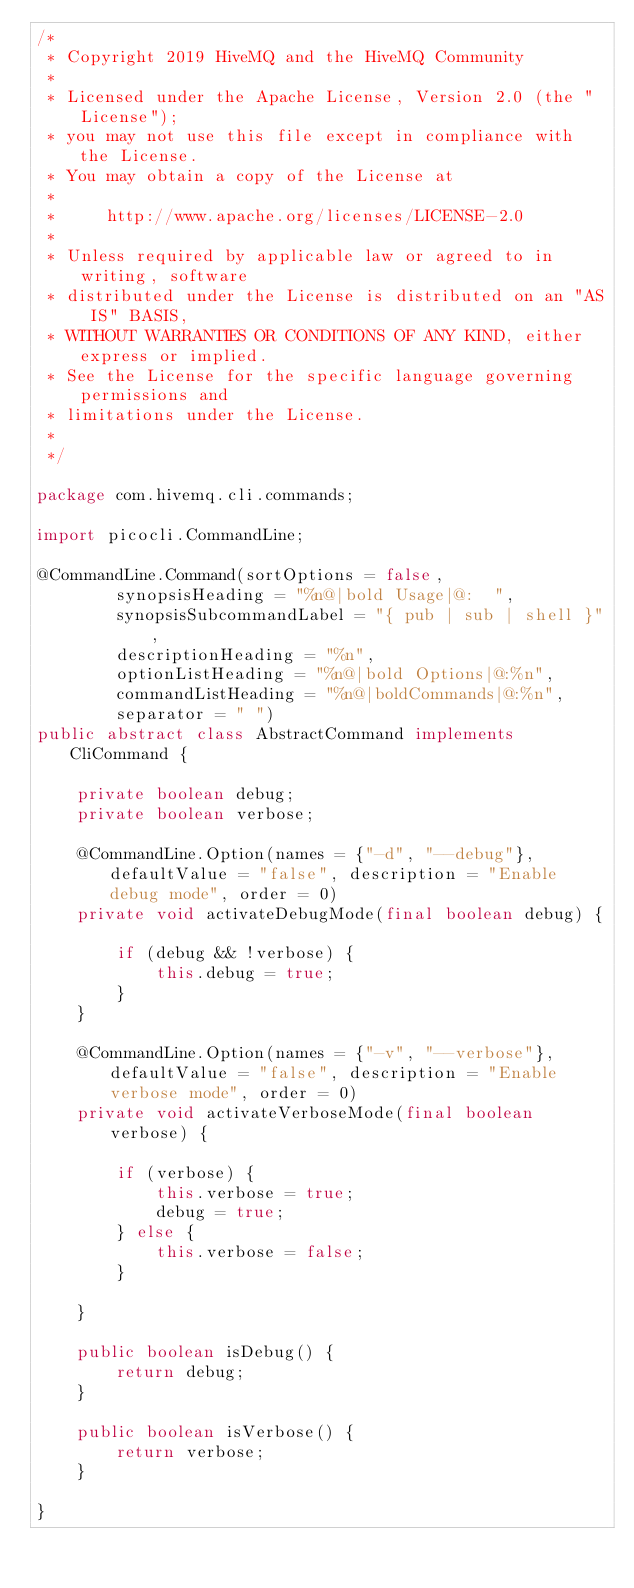Convert code to text. <code><loc_0><loc_0><loc_500><loc_500><_Java_>/*
 * Copyright 2019 HiveMQ and the HiveMQ Community
 *
 * Licensed under the Apache License, Version 2.0 (the "License");
 * you may not use this file except in compliance with the License.
 * You may obtain a copy of the License at
 *
 *     http://www.apache.org/licenses/LICENSE-2.0
 *
 * Unless required by applicable law or agreed to in writing, software
 * distributed under the License is distributed on an "AS IS" BASIS,
 * WITHOUT WARRANTIES OR CONDITIONS OF ANY KIND, either express or implied.
 * See the License for the specific language governing permissions and
 * limitations under the License.
 *
 */

package com.hivemq.cli.commands;

import picocli.CommandLine;

@CommandLine.Command(sortOptions = false,
        synopsisHeading = "%n@|bold Usage|@:  ",
        synopsisSubcommandLabel = "{ pub | sub | shell }",
        descriptionHeading = "%n",
        optionListHeading = "%n@|bold Options|@:%n",
        commandListHeading = "%n@|boldCommands|@:%n",
        separator = " ")
public abstract class AbstractCommand implements CliCommand {

    private boolean debug;
    private boolean verbose;

    @CommandLine.Option(names = {"-d", "--debug"}, defaultValue = "false", description = "Enable debug mode", order = 0)
    private void activateDebugMode(final boolean debug) {

        if (debug && !verbose) {
            this.debug = true;
        }
    }

    @CommandLine.Option(names = {"-v", "--verbose"}, defaultValue = "false", description = "Enable verbose mode", order = 0)
    private void activateVerboseMode(final boolean verbose) {

        if (verbose) {
            this.verbose = true;
            debug = true;
        } else {
            this.verbose = false;
        }

    }

    public boolean isDebug() {
        return debug;
    }

    public boolean isVerbose() {
        return verbose;
    }

}
</code> 